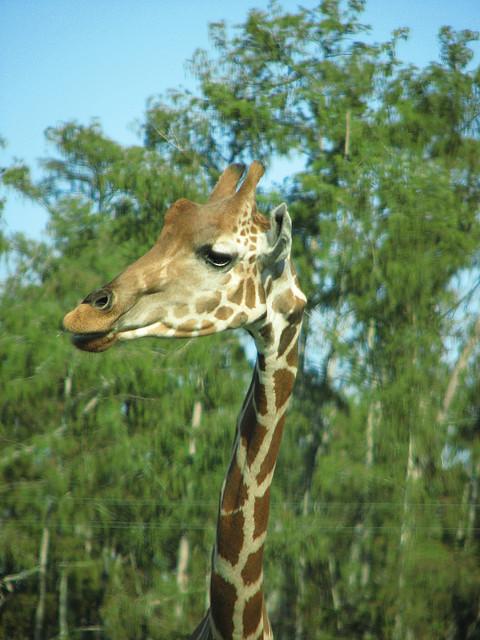Is the giraffe's head wider than its neck?
Answer briefly. Yes. How many giraffes are in the photo?
Give a very brief answer. 1. What type of animal is this?
Answer briefly. Giraffe. How many spots can be counted?
Keep it brief. 30. 